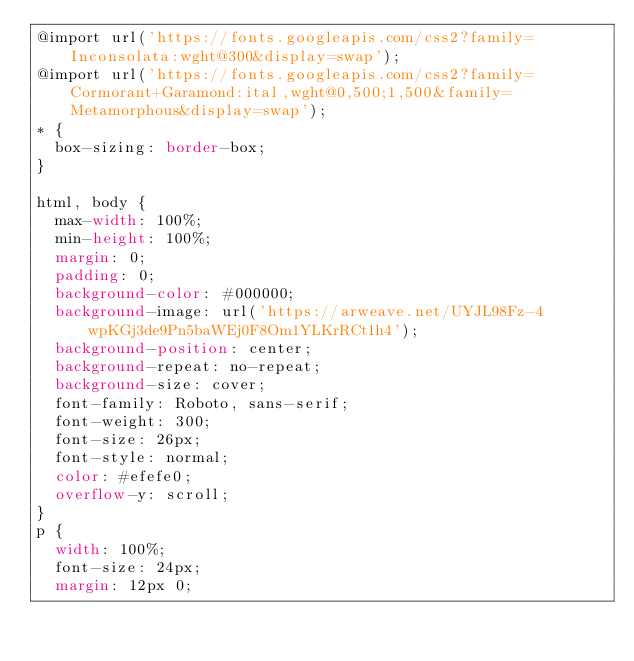<code> <loc_0><loc_0><loc_500><loc_500><_CSS_>@import url('https://fonts.googleapis.com/css2?family=Inconsolata:wght@300&display=swap');
@import url('https://fonts.googleapis.com/css2?family=Cormorant+Garamond:ital,wght@0,500;1,500&family=Metamorphous&display=swap');
* {
  box-sizing: border-box;
}

html, body {
  max-width: 100%;
  min-height: 100%;
  margin: 0;
  padding: 0;
  background-color: #000000;
  background-image: url('https://arweave.net/UYJL98Fz-4wpKGj3de9Pn5baWEj0F8Om1YLKrRCt1h4');
  background-position: center;
  background-repeat: no-repeat;
  background-size: cover;
  font-family: Roboto, sans-serif;
  font-weight: 300;
  font-size: 26px;
  font-style: normal;
  color: #efefe0;
  overflow-y: scroll;
}
p {
  width: 100%;
  font-size: 24px;
  margin: 12px 0;</code> 